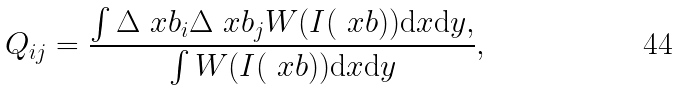Convert formula to latex. <formula><loc_0><loc_0><loc_500><loc_500>Q _ { i j } = \frac { \int \Delta \ x b _ { i } \Delta \ x b _ { j } W ( I ( \ x b ) ) { \mathrm d } x { \mathrm d } y , } { \int W ( I ( \ x b ) ) { \mathrm d } x { \mathrm d } y } ,</formula> 